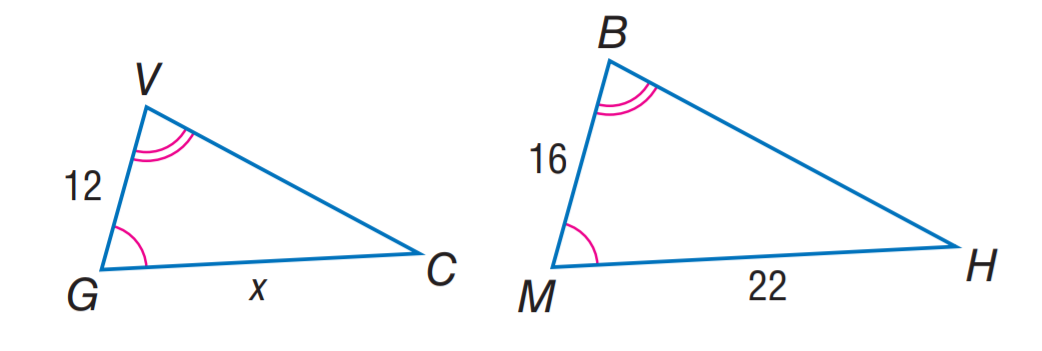Answer the mathemtical geometry problem and directly provide the correct option letter.
Question: Two triangles are similar. Find x.
Choices: A: 11 B: 12 C: 13.5 D: 16.5 D 